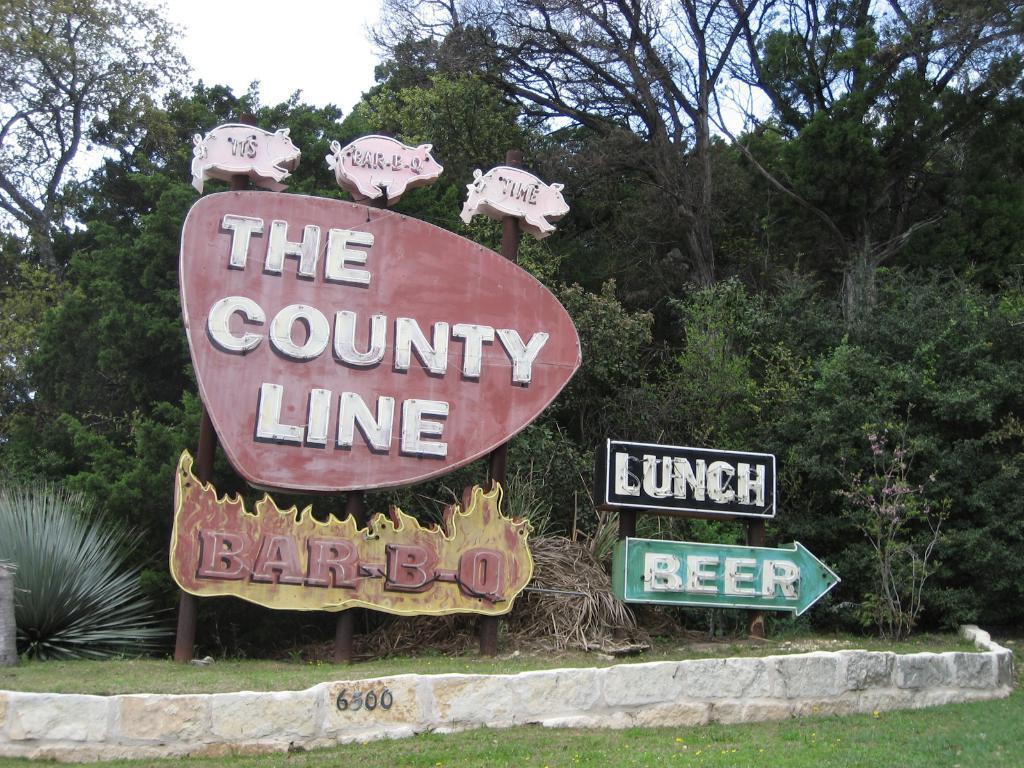Describe this image in one or two sentences. We can see boards on poles, wall, grass, plants and trees. In the background we can see sky. 